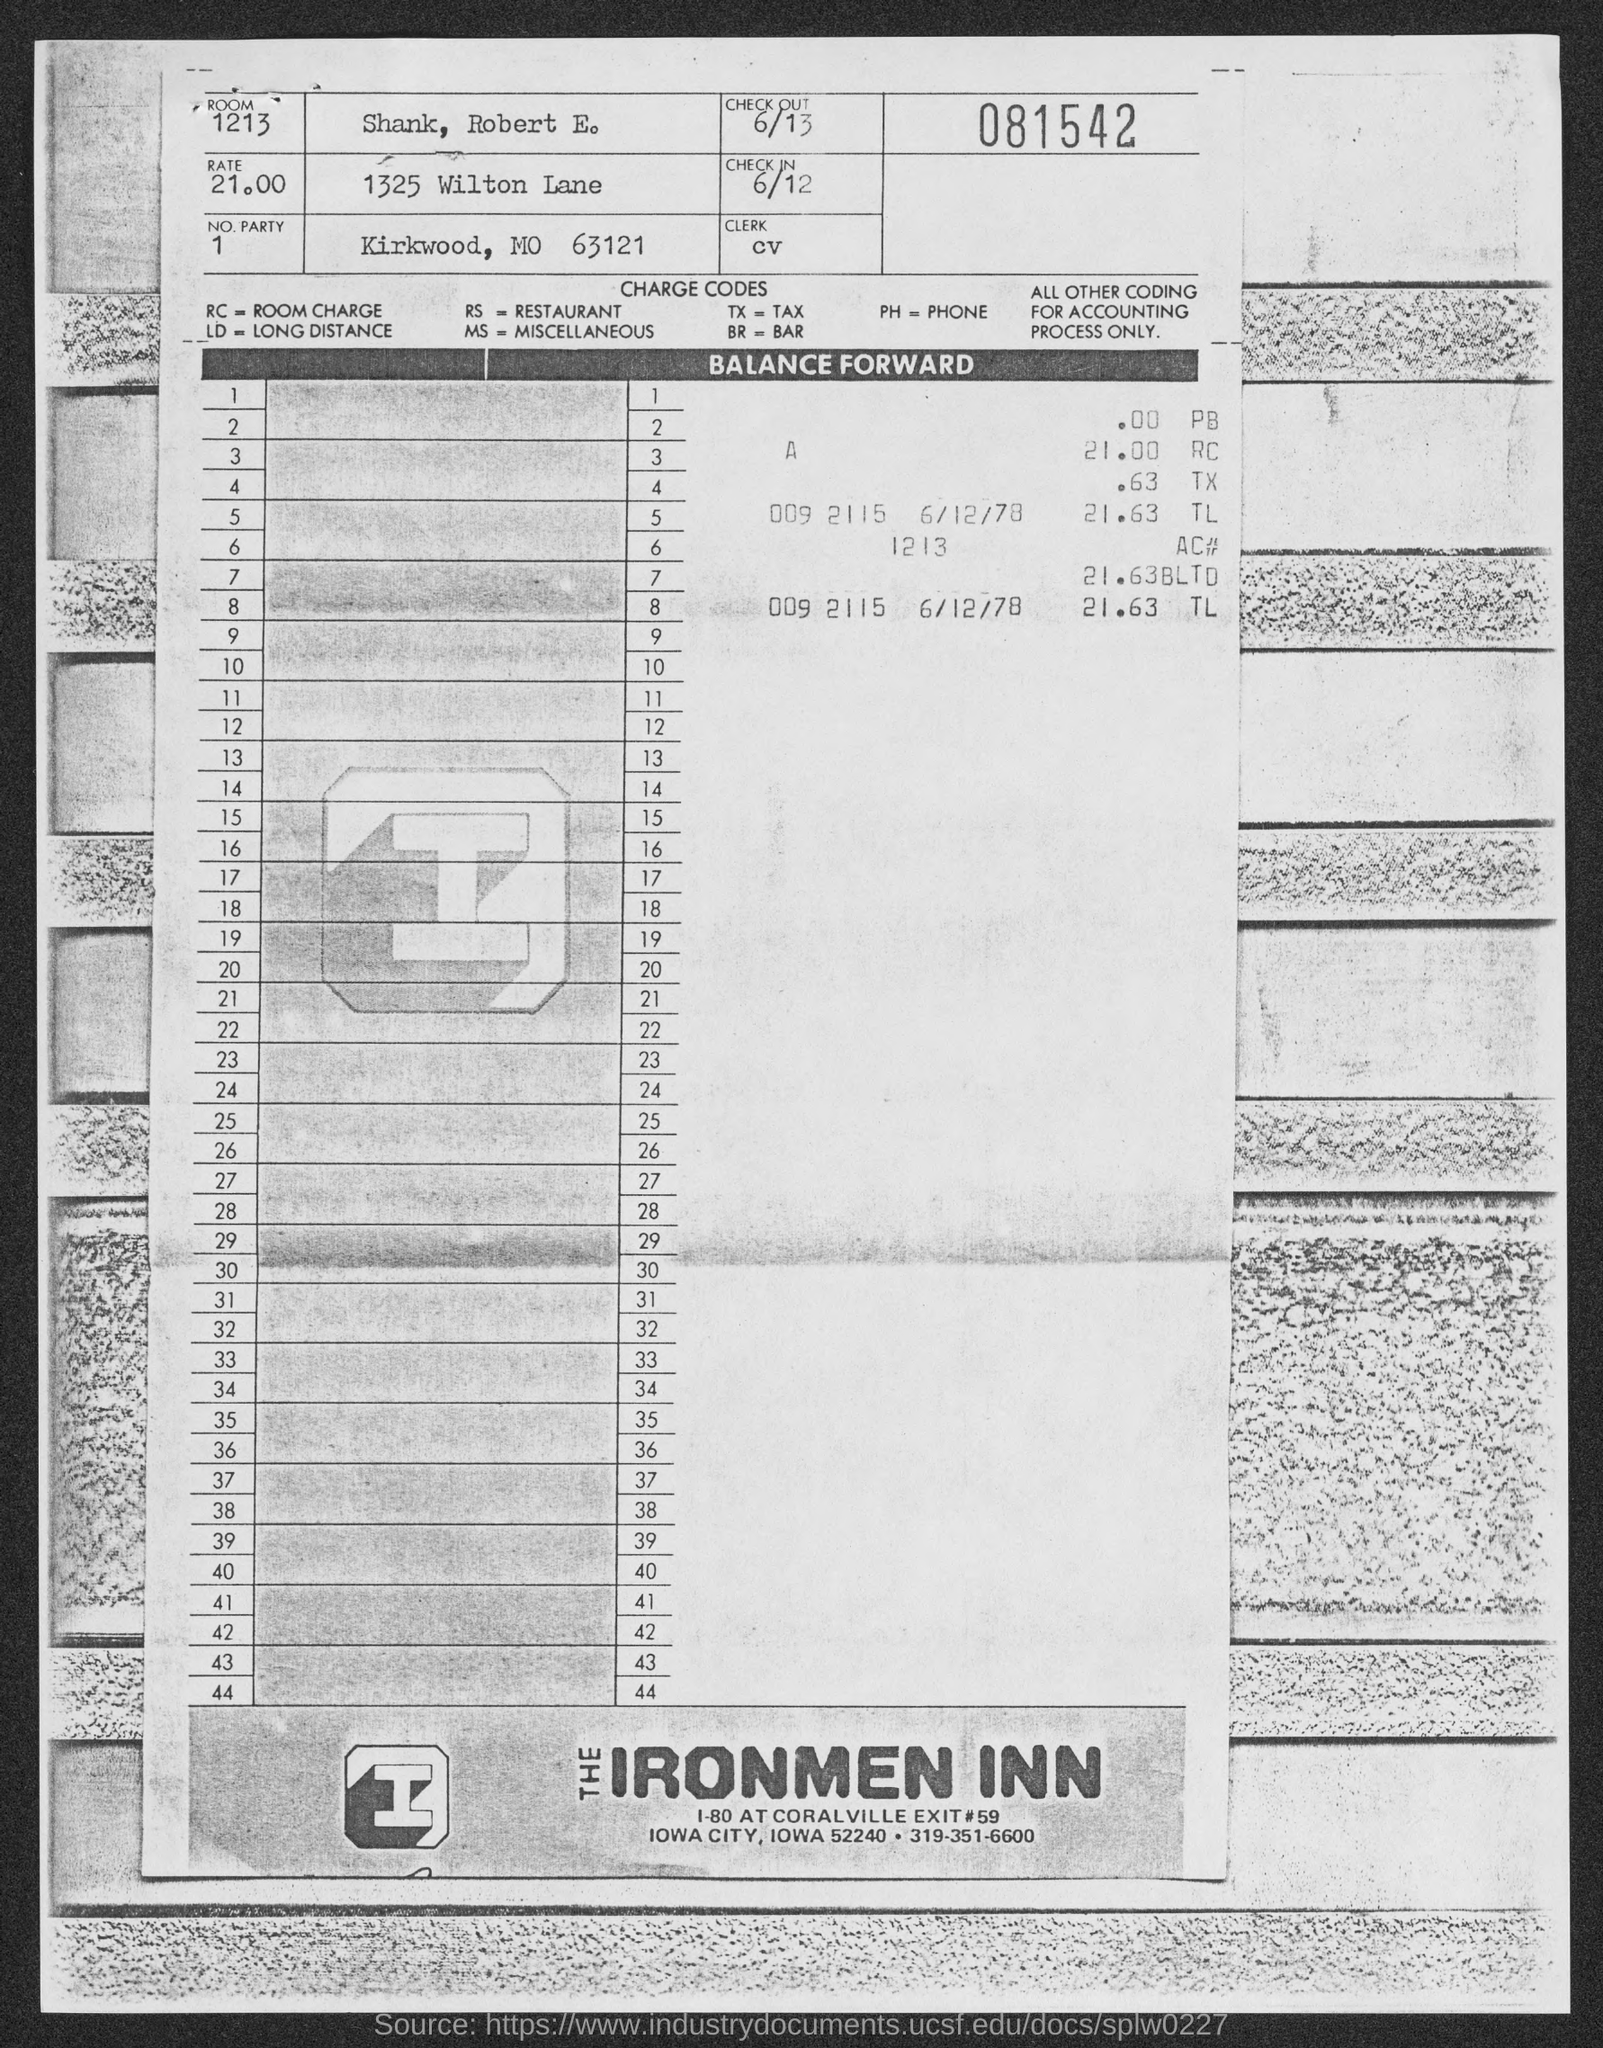What is the room no mentioned in the given page ?
Keep it short and to the point. 1213. What is the rate mentioned in the given page ?
Ensure brevity in your answer.  21.00. What is the no. party mentioned in the given page ?
Make the answer very short. 1. What is the check out date mentioned in the given page ?
Offer a very short reply. 6/13. What is the check in date mentioned in the given page ?
Make the answer very short. 6/12. What is the name of person mentioned in the given page ?
Your answer should be compact. Shank , Robert E. What is the charge code of rc as mentioned in the given page ?
Your response must be concise. ROOM CHARGE. What is the full form of ld as mentioned in the given form ?
Offer a terse response. Long Distance. 